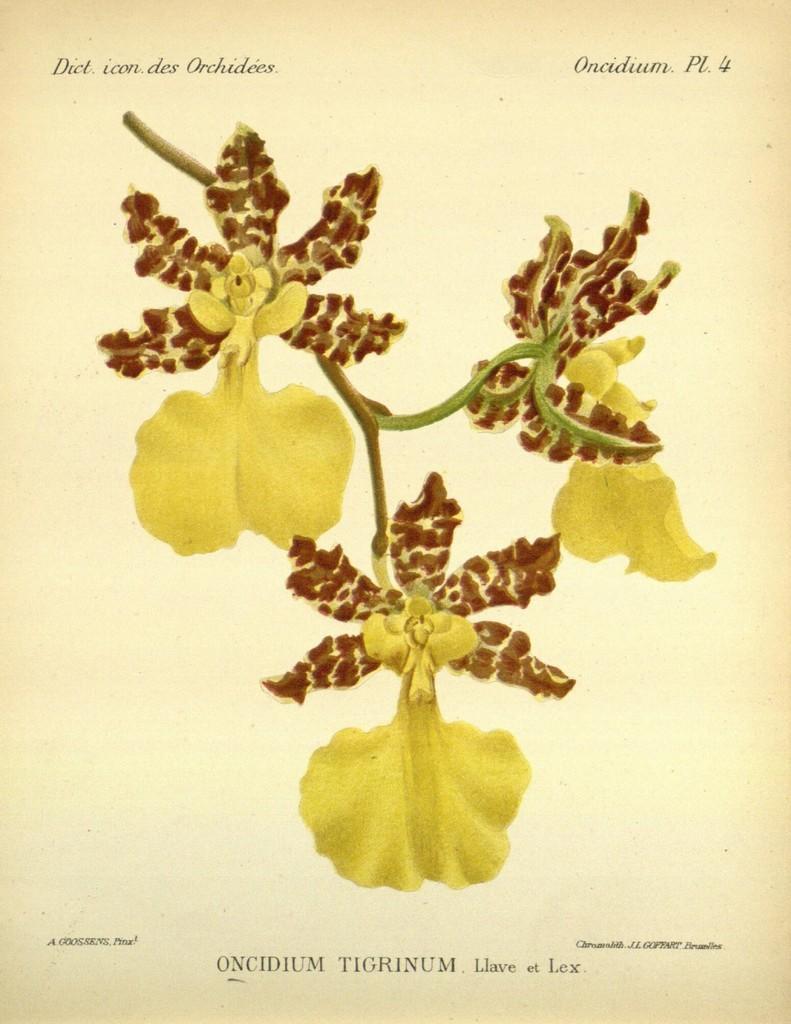What number is shown on the top right?
Provide a short and direct response. 4. What is written at the bottom of the page?
Give a very brief answer. Oncidium tigrinum. 